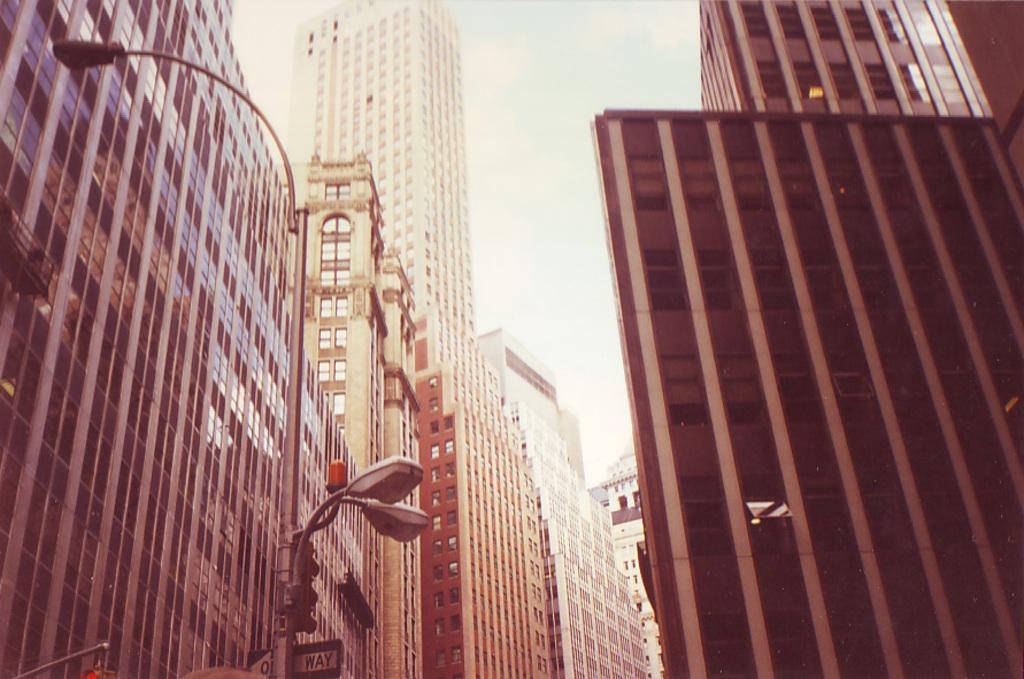Provide a one-sentence caption for the provided image. A streetlight with a sign that has the word WAY visible on it. 